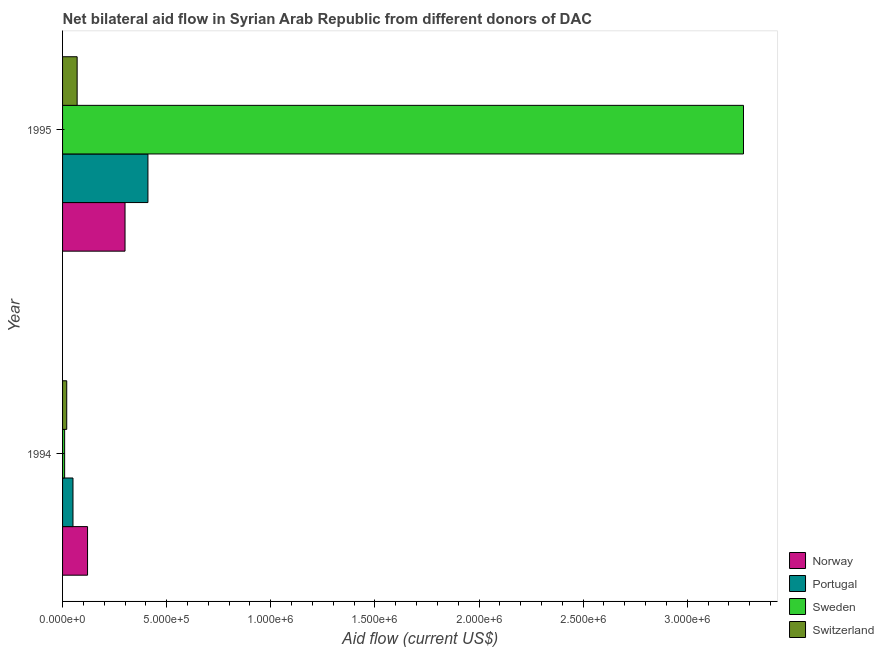How many different coloured bars are there?
Offer a terse response. 4. How many groups of bars are there?
Your answer should be very brief. 2. How many bars are there on the 2nd tick from the top?
Provide a succinct answer. 4. How many bars are there on the 1st tick from the bottom?
Make the answer very short. 4. What is the label of the 2nd group of bars from the top?
Make the answer very short. 1994. In how many cases, is the number of bars for a given year not equal to the number of legend labels?
Give a very brief answer. 0. What is the amount of aid given by portugal in 1995?
Provide a succinct answer. 4.10e+05. Across all years, what is the maximum amount of aid given by norway?
Your answer should be very brief. 3.00e+05. Across all years, what is the minimum amount of aid given by norway?
Your answer should be very brief. 1.20e+05. In which year was the amount of aid given by portugal maximum?
Keep it short and to the point. 1995. In which year was the amount of aid given by portugal minimum?
Your answer should be very brief. 1994. What is the total amount of aid given by sweden in the graph?
Offer a very short reply. 3.28e+06. What is the difference between the amount of aid given by portugal in 1994 and that in 1995?
Your answer should be compact. -3.60e+05. What is the difference between the amount of aid given by portugal in 1994 and the amount of aid given by sweden in 1995?
Provide a succinct answer. -3.22e+06. What is the average amount of aid given by sweden per year?
Make the answer very short. 1.64e+06. In the year 1995, what is the difference between the amount of aid given by sweden and amount of aid given by switzerland?
Provide a succinct answer. 3.20e+06. What is the ratio of the amount of aid given by switzerland in 1994 to that in 1995?
Offer a terse response. 0.29. Is the difference between the amount of aid given by portugal in 1994 and 1995 greater than the difference between the amount of aid given by switzerland in 1994 and 1995?
Keep it short and to the point. No. In how many years, is the amount of aid given by sweden greater than the average amount of aid given by sweden taken over all years?
Provide a short and direct response. 1. Is it the case that in every year, the sum of the amount of aid given by sweden and amount of aid given by switzerland is greater than the sum of amount of aid given by portugal and amount of aid given by norway?
Provide a succinct answer. No. How many bars are there?
Your response must be concise. 8. Are all the bars in the graph horizontal?
Your answer should be compact. Yes. What is the difference between two consecutive major ticks on the X-axis?
Your answer should be very brief. 5.00e+05. Does the graph contain any zero values?
Your answer should be very brief. No. Does the graph contain grids?
Provide a succinct answer. No. How are the legend labels stacked?
Your answer should be very brief. Vertical. What is the title of the graph?
Your response must be concise. Net bilateral aid flow in Syrian Arab Republic from different donors of DAC. Does "Fourth 20% of population" appear as one of the legend labels in the graph?
Offer a terse response. No. What is the label or title of the X-axis?
Offer a terse response. Aid flow (current US$). What is the Aid flow (current US$) in Norway in 1994?
Offer a terse response. 1.20e+05. What is the Aid flow (current US$) of Portugal in 1994?
Keep it short and to the point. 5.00e+04. What is the Aid flow (current US$) in Sweden in 1994?
Offer a very short reply. 10000. What is the Aid flow (current US$) in Switzerland in 1994?
Ensure brevity in your answer.  2.00e+04. What is the Aid flow (current US$) of Norway in 1995?
Keep it short and to the point. 3.00e+05. What is the Aid flow (current US$) of Portugal in 1995?
Ensure brevity in your answer.  4.10e+05. What is the Aid flow (current US$) of Sweden in 1995?
Your answer should be compact. 3.27e+06. Across all years, what is the maximum Aid flow (current US$) of Norway?
Your answer should be compact. 3.00e+05. Across all years, what is the maximum Aid flow (current US$) in Portugal?
Give a very brief answer. 4.10e+05. Across all years, what is the maximum Aid flow (current US$) of Sweden?
Ensure brevity in your answer.  3.27e+06. Across all years, what is the maximum Aid flow (current US$) of Switzerland?
Offer a very short reply. 7.00e+04. Across all years, what is the minimum Aid flow (current US$) of Portugal?
Your response must be concise. 5.00e+04. What is the total Aid flow (current US$) of Portugal in the graph?
Provide a short and direct response. 4.60e+05. What is the total Aid flow (current US$) of Sweden in the graph?
Your response must be concise. 3.28e+06. What is the difference between the Aid flow (current US$) of Norway in 1994 and that in 1995?
Provide a short and direct response. -1.80e+05. What is the difference between the Aid flow (current US$) of Portugal in 1994 and that in 1995?
Your answer should be very brief. -3.60e+05. What is the difference between the Aid flow (current US$) of Sweden in 1994 and that in 1995?
Ensure brevity in your answer.  -3.26e+06. What is the difference between the Aid flow (current US$) in Switzerland in 1994 and that in 1995?
Keep it short and to the point. -5.00e+04. What is the difference between the Aid flow (current US$) in Norway in 1994 and the Aid flow (current US$) in Sweden in 1995?
Make the answer very short. -3.15e+06. What is the difference between the Aid flow (current US$) in Portugal in 1994 and the Aid flow (current US$) in Sweden in 1995?
Ensure brevity in your answer.  -3.22e+06. What is the difference between the Aid flow (current US$) in Sweden in 1994 and the Aid flow (current US$) in Switzerland in 1995?
Offer a terse response. -6.00e+04. What is the average Aid flow (current US$) in Norway per year?
Your answer should be compact. 2.10e+05. What is the average Aid flow (current US$) in Sweden per year?
Give a very brief answer. 1.64e+06. What is the average Aid flow (current US$) of Switzerland per year?
Your answer should be very brief. 4.50e+04. In the year 1994, what is the difference between the Aid flow (current US$) in Norway and Aid flow (current US$) in Sweden?
Offer a very short reply. 1.10e+05. In the year 1994, what is the difference between the Aid flow (current US$) in Portugal and Aid flow (current US$) in Sweden?
Your response must be concise. 4.00e+04. In the year 1994, what is the difference between the Aid flow (current US$) in Portugal and Aid flow (current US$) in Switzerland?
Offer a very short reply. 3.00e+04. In the year 1994, what is the difference between the Aid flow (current US$) in Sweden and Aid flow (current US$) in Switzerland?
Provide a succinct answer. -10000. In the year 1995, what is the difference between the Aid flow (current US$) in Norway and Aid flow (current US$) in Sweden?
Ensure brevity in your answer.  -2.97e+06. In the year 1995, what is the difference between the Aid flow (current US$) of Portugal and Aid flow (current US$) of Sweden?
Offer a very short reply. -2.86e+06. In the year 1995, what is the difference between the Aid flow (current US$) in Portugal and Aid flow (current US$) in Switzerland?
Keep it short and to the point. 3.40e+05. In the year 1995, what is the difference between the Aid flow (current US$) in Sweden and Aid flow (current US$) in Switzerland?
Keep it short and to the point. 3.20e+06. What is the ratio of the Aid flow (current US$) in Portugal in 1994 to that in 1995?
Make the answer very short. 0.12. What is the ratio of the Aid flow (current US$) in Sweden in 1994 to that in 1995?
Your answer should be compact. 0. What is the ratio of the Aid flow (current US$) of Switzerland in 1994 to that in 1995?
Provide a short and direct response. 0.29. What is the difference between the highest and the second highest Aid flow (current US$) in Norway?
Ensure brevity in your answer.  1.80e+05. What is the difference between the highest and the second highest Aid flow (current US$) of Portugal?
Offer a very short reply. 3.60e+05. What is the difference between the highest and the second highest Aid flow (current US$) in Sweden?
Offer a very short reply. 3.26e+06. What is the difference between the highest and the lowest Aid flow (current US$) in Norway?
Keep it short and to the point. 1.80e+05. What is the difference between the highest and the lowest Aid flow (current US$) of Portugal?
Keep it short and to the point. 3.60e+05. What is the difference between the highest and the lowest Aid flow (current US$) in Sweden?
Give a very brief answer. 3.26e+06. 